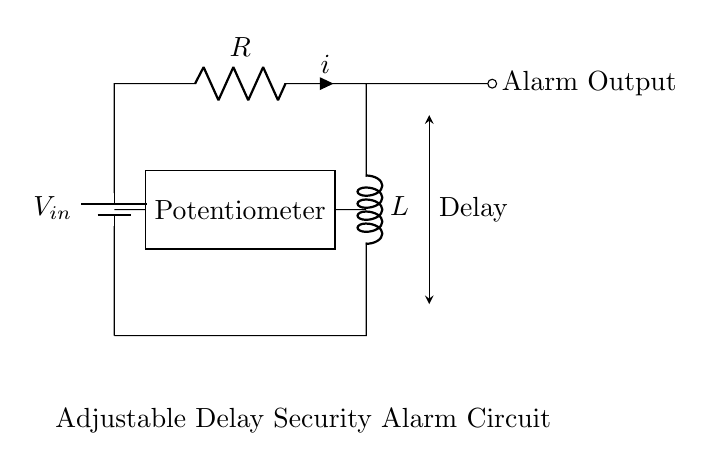What is the voltage source in this circuit? The voltage source in the circuit is labeled as \( V_{in} \). This indicates the potential difference that powers the circuit.
Answer: \( V_{in} \) What is the purpose of the inductor in this circuit? The inductor helps in creating a delay in the current flow due to its ability to store energy in a magnetic field. The delay is important in an alarm system to allow for a set timing before triggering the output.
Answer: Delay What component is used to adjust the timing? The circuit includes a potentiometer, which is used to adjust the resistance and therefore the timing for the alarm system.
Answer: Potentiometer What does the alarm output indicate in this circuit? The alarm output is where the triggered signal for the alarm is sent when the conditions of the circuit are met, indicating that an alarm condition exists.
Answer: Alarm Output What relationship does the resistor have with the inductor in this circuit? The resistor limits the current flowing through the circuit, which in combination with the inductor's properties, affects the time constant and the delay before the alarm is triggered. Thus, both components work together to define the circuit's response time.
Answer: Time Constant How does changing the potentiometer affect the circuit? Adjusting the potentiometer changes the resistance in the circuit, which alters the time constant (the product of resistance and inductance) and therefore the delay before the alarm is activated.
Answer: Changes Delay 